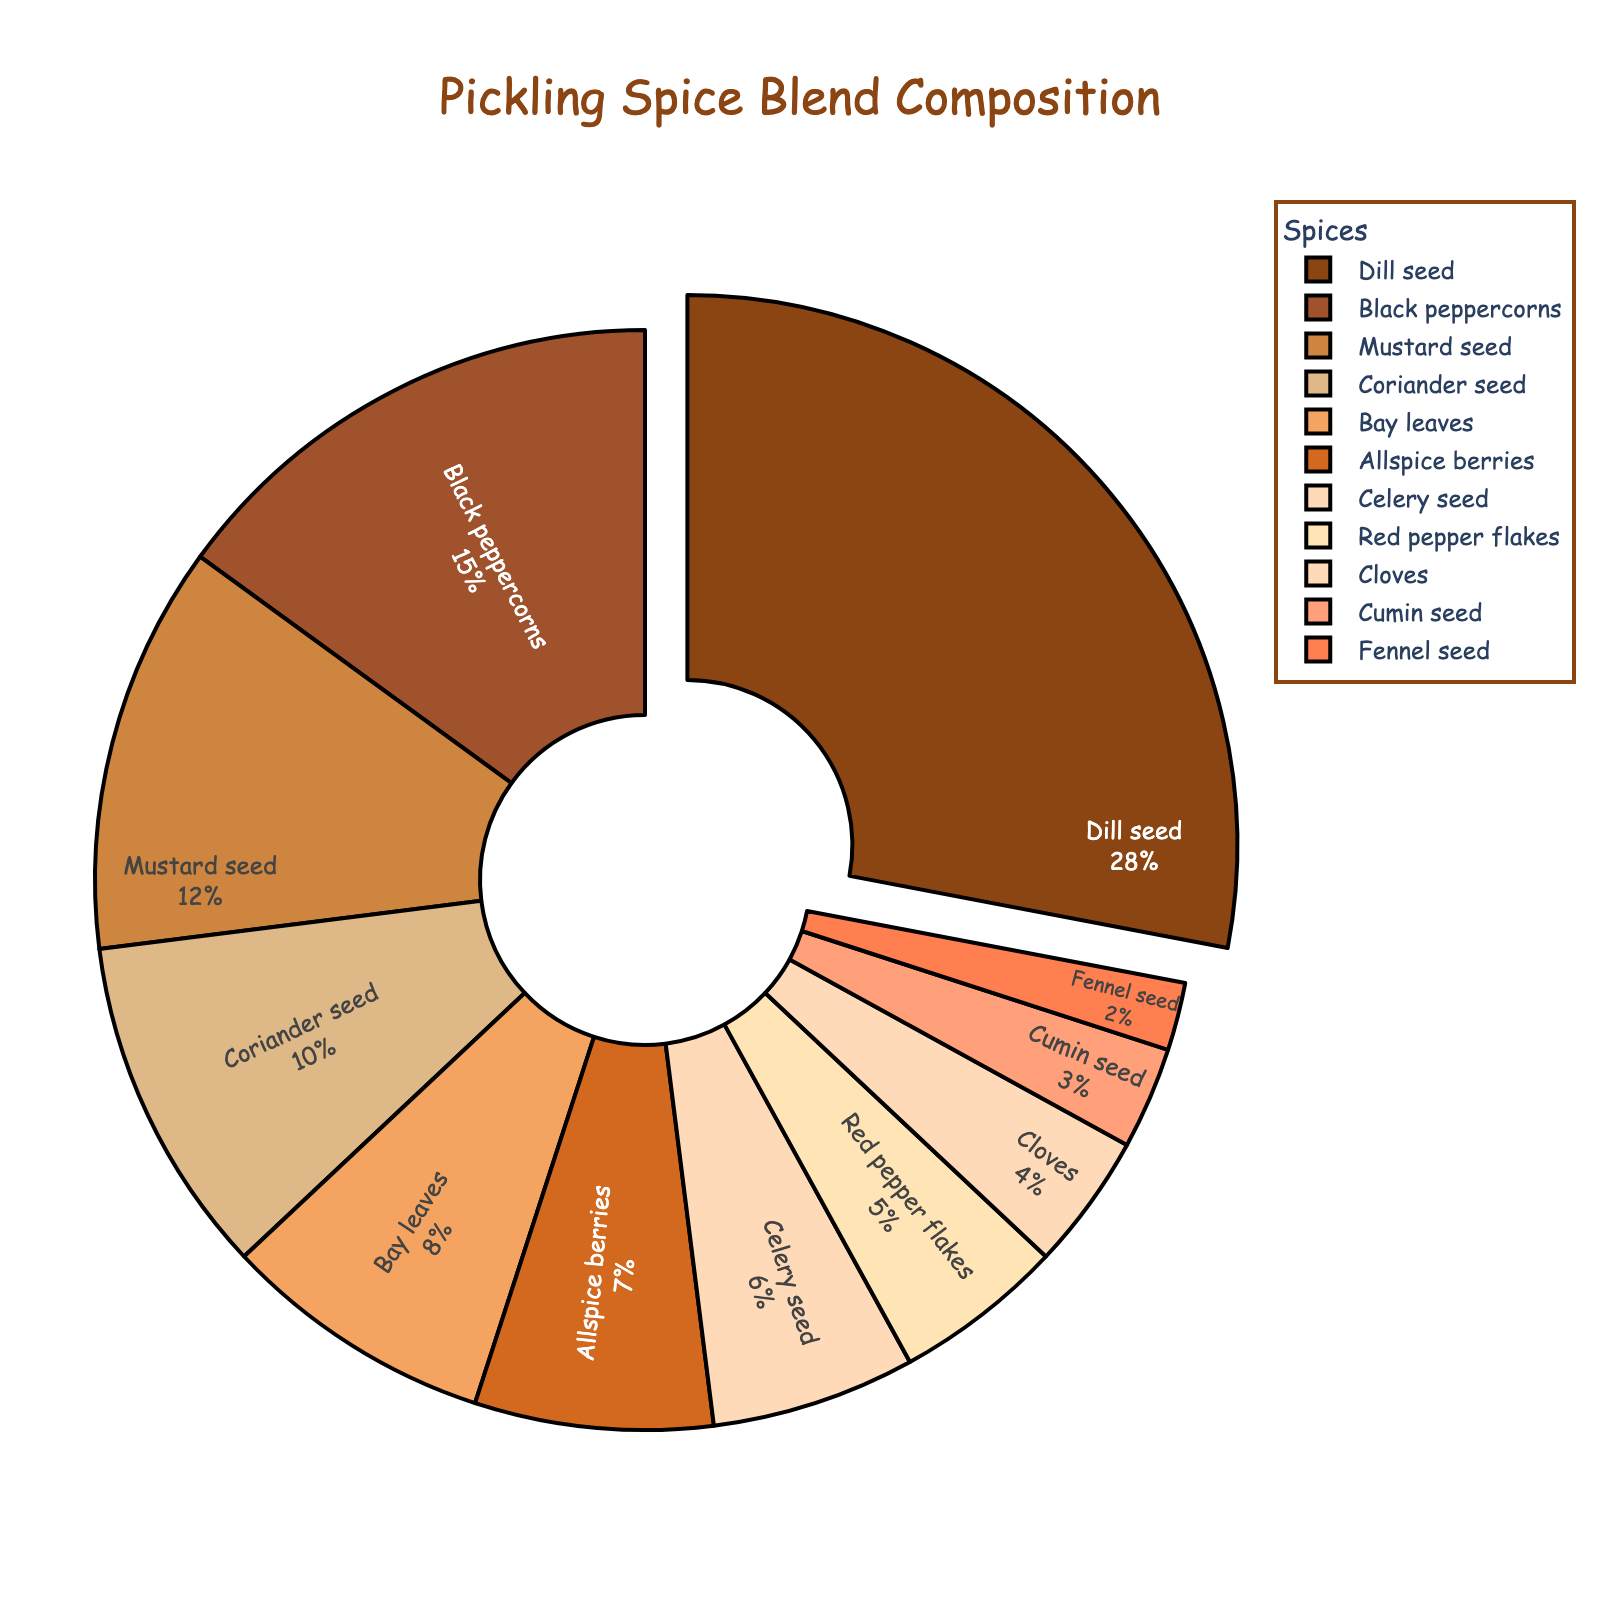Which spice has the largest percentage in the pickling spice blend? Dill seed has the largest percentage of 28%, as shown by the slice that is pulled out and is the largest part of the pie chart.
Answer: Dill seed Which two spices have the smallest percentages and what are their values? The two smallest slices of the pie chart represent Fennel seed (2%) and Cumin seed (3%).
Answer: Fennel seed and Cumin seed How many spices have a percentage higher than 10%? By visually identifying the slices larger than 10%, Dill seed (28%), Black peppercorns (15%), and Mustard seed (12%) surpass this threshold.
Answer: Three What is the combined percentage of Allspice berries, Celery seed, and Red pepper flakes? Add the percentages of each spice: Allspice berries (7%) + Celery seed (6%) + Red pepper flakes (5%) equals 18%.
Answer: 18% Which spices have equivalent percentages visually? The slices representing Mustard seed (12%) and Coriander seed (10%) look similar in size but are not equal. Only the two 5% slices, Red pepper flakes and Bay leaves, are equal visually.
Answer: Red pepper flakes and Bay leaves Is the percentage of Black peppercorns greater than the combined percentage of Celery seed and Cloves? Calculate the sum of Celery seed (6%) and Cloves (4%), which is 10%. Compare this with Black peppercorns, which is 15%.
Answer: Yes What percentage of spices is represented by Coriander seed and Bay leaves together? Add Coriander seed (10%) and Bay leaves (8%) to get 18%.
Answer: 18% Arrange the spices in order starting from the one with the smallest percentage. The smallest is Fennel seed (2%), followed by Cumin seed (3%), Cloves (4%), Red pepper flakes (5%), Celery seed (6%), Allspice berries (7%), Bay leaves (8%), Coriander seed (10%), Mustard seed (12%), Black peppercorns (15%), and finally, Dill seed (28%).
Answer: Fennel seed, Cumin seed, Cloves, Red pepper flakes, Celery seed, Allspice berries, Bay leaves, Coriander seed, Mustard seed, Black peppercorns, Dill seed How does the slice size of Mustard seed compare to that of Dill seed? Mustard seed (12%) is less than half of Dill seed (28%), which is evident from visually comparing the sizes of their respective slices.
Answer: Less than half What is the median percentage value of all the spices? Arrange the percentages in ascending order: 2, 3, 4, 5, 6, 7, 8, 10, 12, 15, 28. The median value, being the middle number, is 7%.
Answer: 7% 